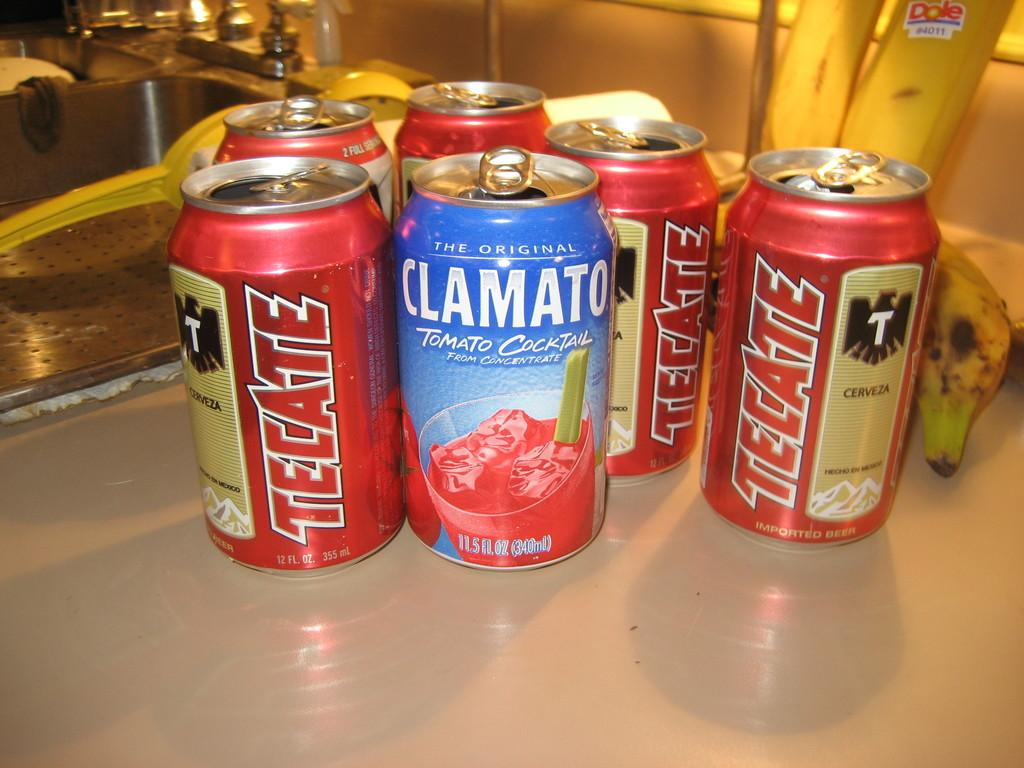Provide a one-sentence caption for the provided image. One of the several cans contains Clamato Tomato cocktail. 